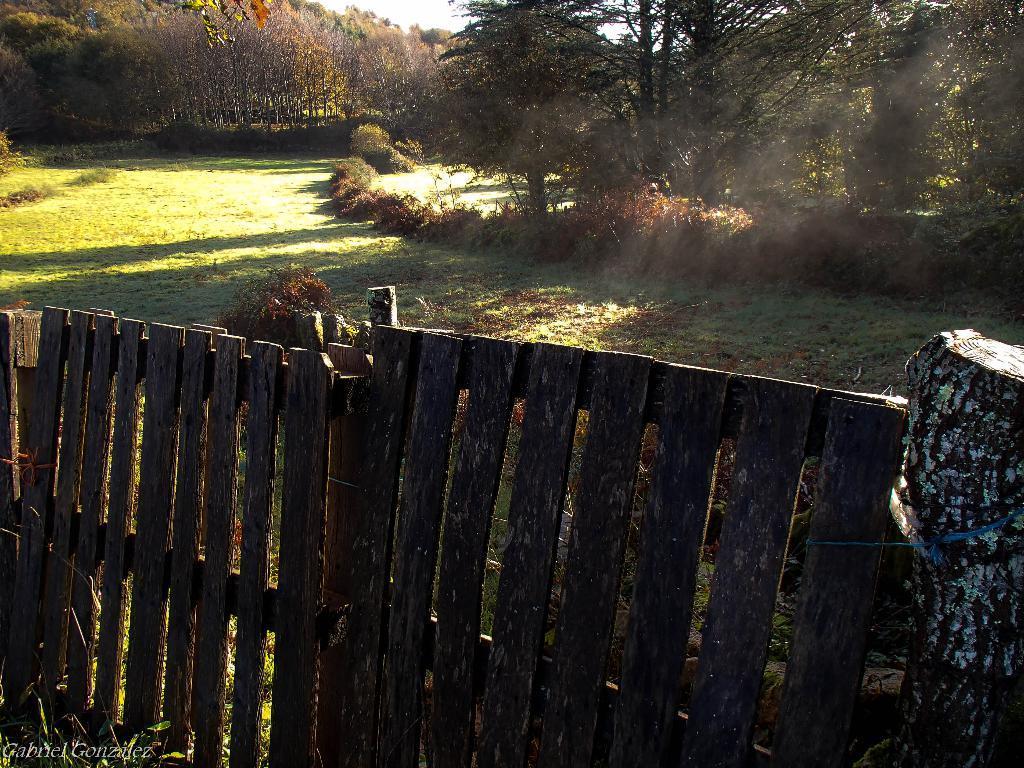Please provide a concise description of this image. In this image we can see land full of grass, trees and wooden fencing. 